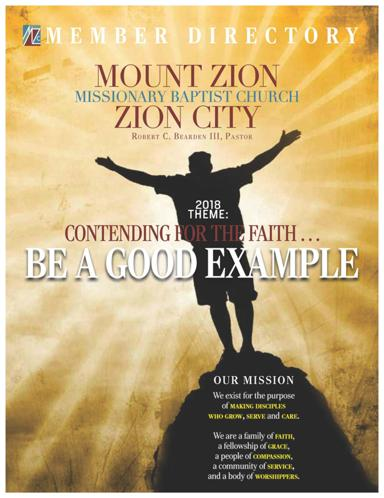What is the mission of the church? The mission of Mount Zion Missionary Baptist Church is clearly articulated to strengthen its members through growth, service, and compassionate care. This mission emphasizes creating a supportive and engaged community which is reflected in their activities and how they present themselves. 